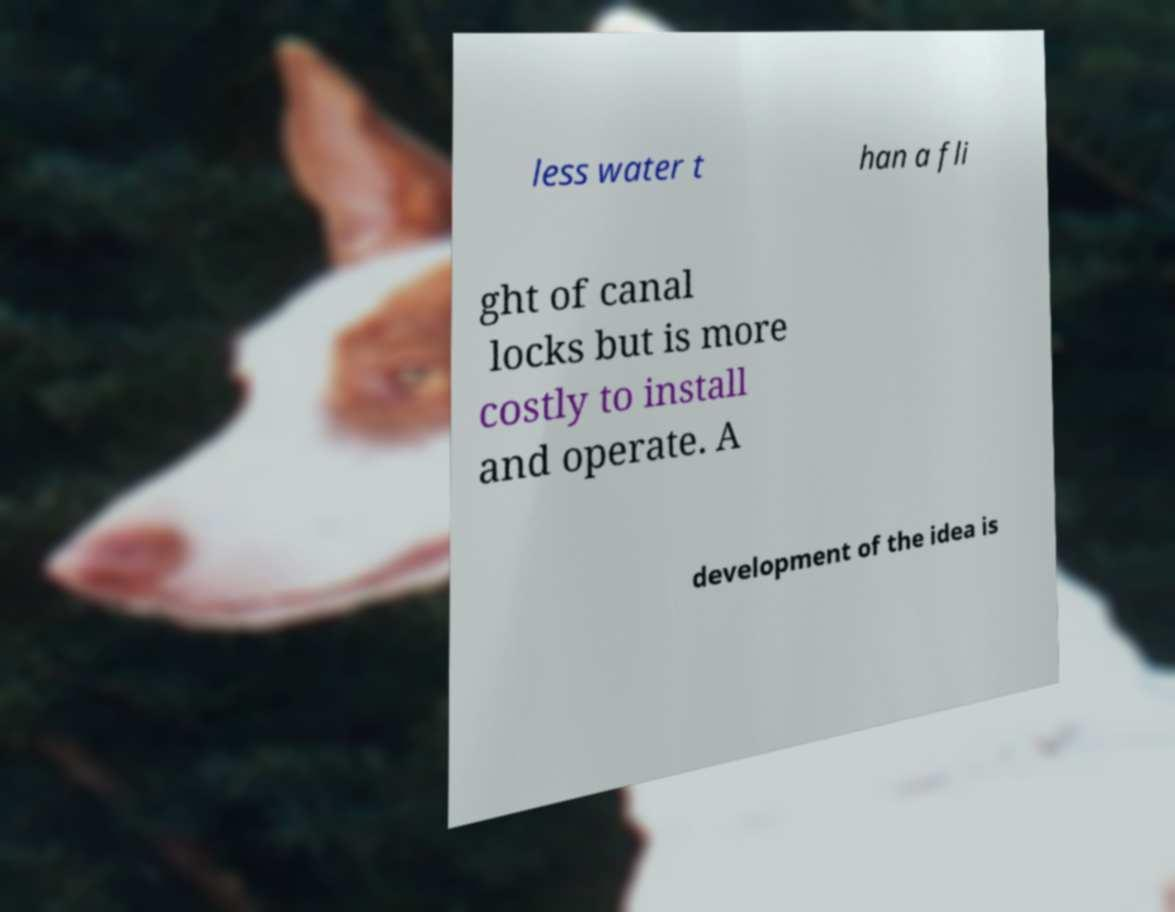Please read and relay the text visible in this image. What does it say? less water t han a fli ght of canal locks but is more costly to install and operate. A development of the idea is 